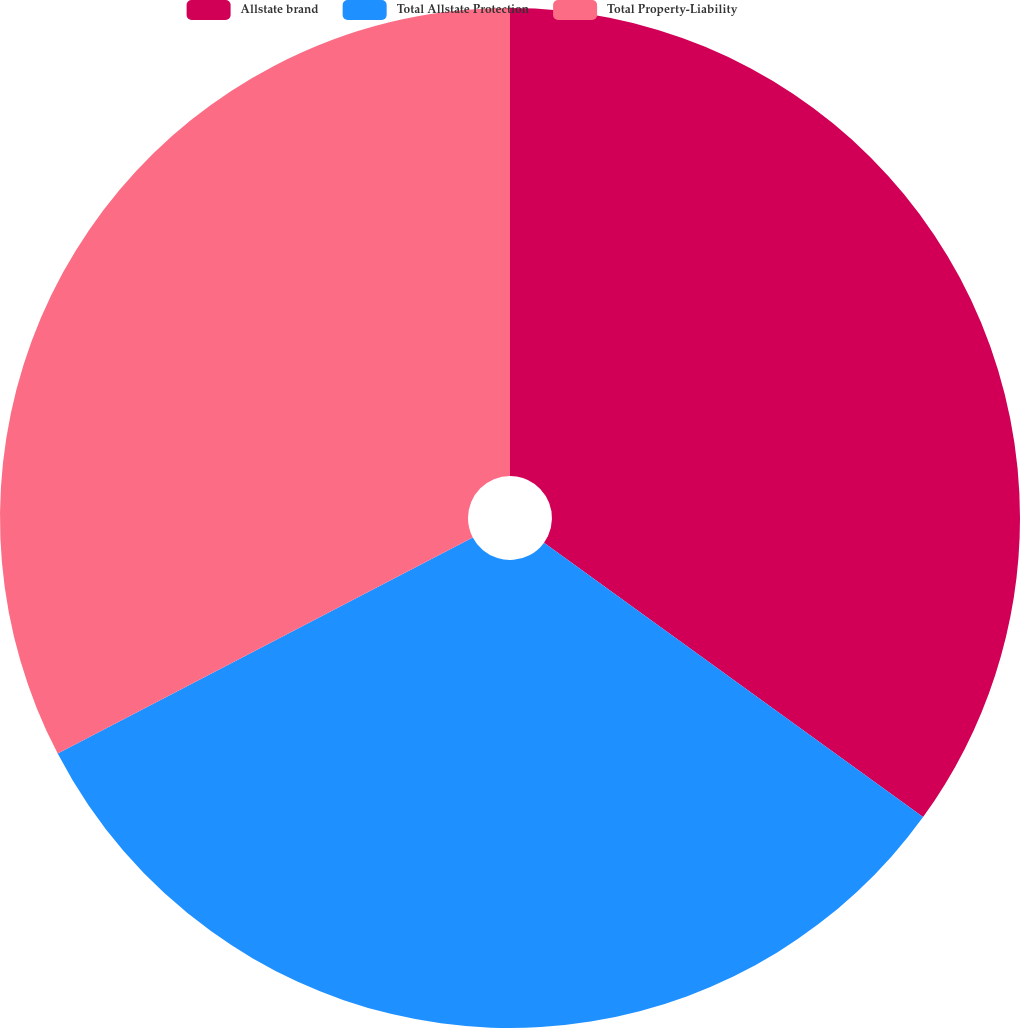<chart> <loc_0><loc_0><loc_500><loc_500><pie_chart><fcel>Allstate brand<fcel>Total Allstate Protection<fcel>Total Property-Liability<nl><fcel>34.97%<fcel>32.38%<fcel>32.64%<nl></chart> 